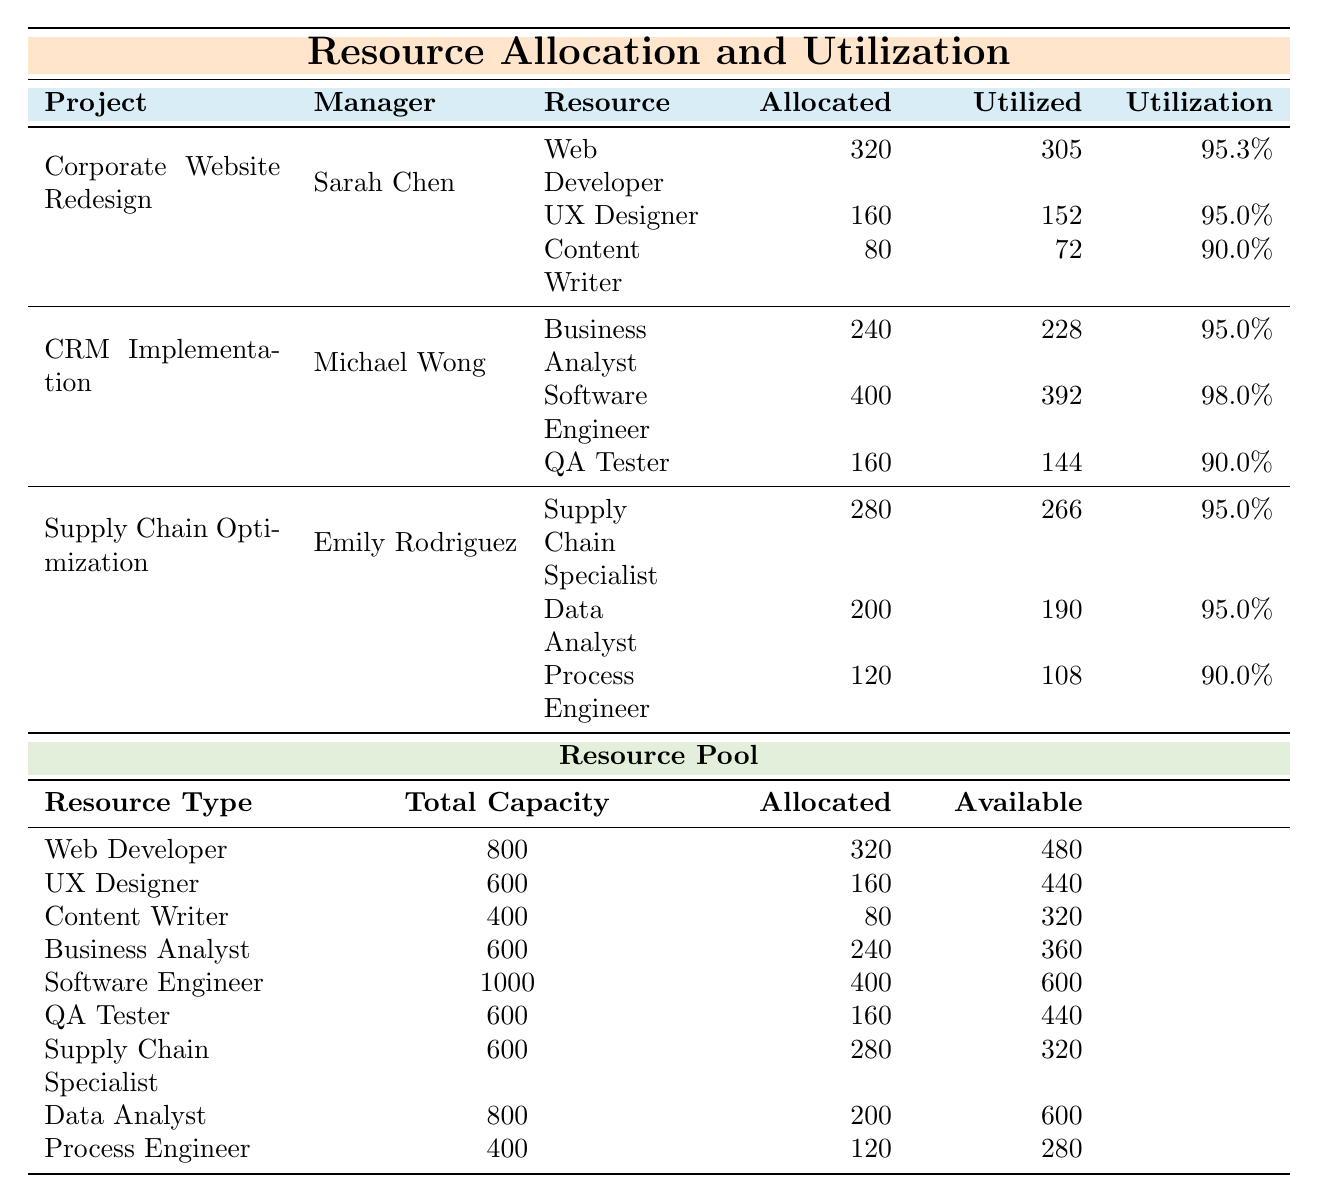What is the utilization rate of the Web Developer in the Corporate Website Redesign project? The table shows that the Utilization Rate for the Web Developer is listed as 95.3% in the Corporate Website Redesign project.
Answer: 95.3% Which project has the highest allocated hours for resources? By comparing the allocated hours for each project, the CRM Implementation project has the highest allocation at 400 hours for the Software Engineer, totaling 400 + 240 + 160 = 800 hours across all resources.
Answer: CRM Implementation Is the total capacity of the Data Analyst resource greater than its allocated hours? The total capacity for Data Analysts is 800, while the allocated hours are 200. Since 800 is greater than 200, the statement is true.
Answer: Yes How many more hours were utilized than allocated for the Process Engineer in the Supply Chain Optimization project? The allocated hours for the Process Engineer are 120 and the utilized hours are 108. To find the difference: 120 - 108 = 12.
Answer: 12 What is the combined total capacity of the Web Developer and UX Designer? The total capacity for Web Developers is 800 and for UX Designers is 600. Adding these values gives 800 + 600 = 1400.
Answer: 1400 Which resource type has the highest availability? By examining the available hours for each resource type, the Software Engineer has 600 available hours, which is greater than any other resource type.
Answer: Software Engineer What is the average utilization rate for the resources in the CRM Implementation project? The utilization rates for the resources are 95.0%, 98.0%, and 90.0%. The average is (95.0 + 98.0 + 90.0) / 3 = 94.33%.
Answer: 94.33% Are there more allocated hours in the Resource Pool for Business Analysts or Software Engineers? Business Analysts have 240 allocated hours and Software Engineers have 400 allocated hours. Since 400 is greater than 240, Software Engineers have more allocated hours.
Answer: Software Engineers Which project manager has the least utilized hours in their project? Looking at the utilized hours of each project, the Content Writer in the Corporate Website Redesign project has 72 utilized hours, which is less than other project roles.
Answer: Sarah Chen What is the total number of allocated hours across all projects? Adding up all allocated hours from each project: 320 (Web Developer) + 160 (UX Designer) + 80 (Content Writer) for Corporate Website Redesign, 240 (Business Analyst) + 400 (Software Engineer) + 160 (QA Tester) for CRM Implementation, and 280 (Supply Chain Specialist) + 200 (Data Analyst) + 120 (Process Engineer) for Supply Chain Optimization gives a total of 320 + 160 + 80 + 240 + 400 + 160 + 280 + 200 + 120 = 1960.
Answer: 1960 